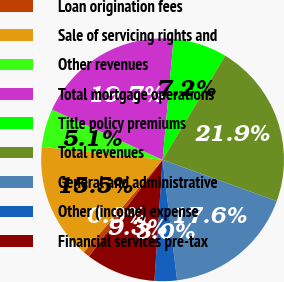Convert chart. <chart><loc_0><loc_0><loc_500><loc_500><pie_chart><fcel>Loan origination fees<fcel>Sale of servicing rights and<fcel>Other revenues<fcel>Total mortgage operations<fcel>Title policy premiums<fcel>Total revenues<fcel>General and administrative<fcel>Other (income) expense<fcel>Financial services pre-tax<nl><fcel>0.88%<fcel>15.47%<fcel>5.08%<fcel>19.67%<fcel>7.18%<fcel>21.9%<fcel>17.57%<fcel>2.98%<fcel>9.28%<nl></chart> 